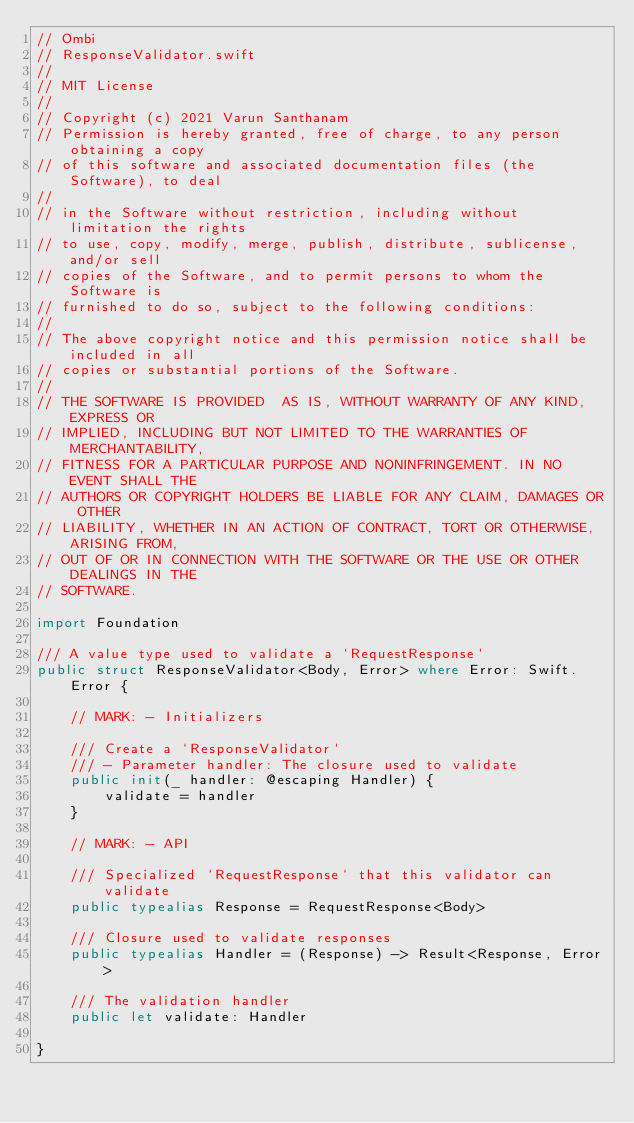<code> <loc_0><loc_0><loc_500><loc_500><_Swift_>// Ombi
// ResponseValidator.swift
//
// MIT License
//
// Copyright (c) 2021 Varun Santhanam
// Permission is hereby granted, free of charge, to any person obtaining a copy
// of this software and associated documentation files (the  Software), to deal
//
// in the Software without restriction, including without limitation the rights
// to use, copy, modify, merge, publish, distribute, sublicense, and/or sell
// copies of the Software, and to permit persons to whom the Software is
// furnished to do so, subject to the following conditions:
//
// The above copyright notice and this permission notice shall be included in all
// copies or substantial portions of the Software.
//
// THE SOFTWARE IS PROVIDED  AS IS, WITHOUT WARRANTY OF ANY KIND, EXPRESS OR
// IMPLIED, INCLUDING BUT NOT LIMITED TO THE WARRANTIES OF MERCHANTABILITY,
// FITNESS FOR A PARTICULAR PURPOSE AND NONINFRINGEMENT. IN NO EVENT SHALL THE
// AUTHORS OR COPYRIGHT HOLDERS BE LIABLE FOR ANY CLAIM, DAMAGES OR OTHER
// LIABILITY, WHETHER IN AN ACTION OF CONTRACT, TORT OR OTHERWISE, ARISING FROM,
// OUT OF OR IN CONNECTION WITH THE SOFTWARE OR THE USE OR OTHER DEALINGS IN THE
// SOFTWARE.

import Foundation

/// A value type used to validate a `RequestResponse`
public struct ResponseValidator<Body, Error> where Error: Swift.Error {

    // MARK: - Initializers

    /// Create a `ResponseValidator`
    /// - Parameter handler: The closure used to validate
    public init(_ handler: @escaping Handler) {
        validate = handler
    }

    // MARK: - API

    /// Specialized `RequestResponse` that this validator can validate
    public typealias Response = RequestResponse<Body>

    /// Closure used to validate responses
    public typealias Handler = (Response) -> Result<Response, Error>

    /// The validation handler
    public let validate: Handler

}
</code> 